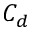<formula> <loc_0><loc_0><loc_500><loc_500>C _ { d }</formula> 